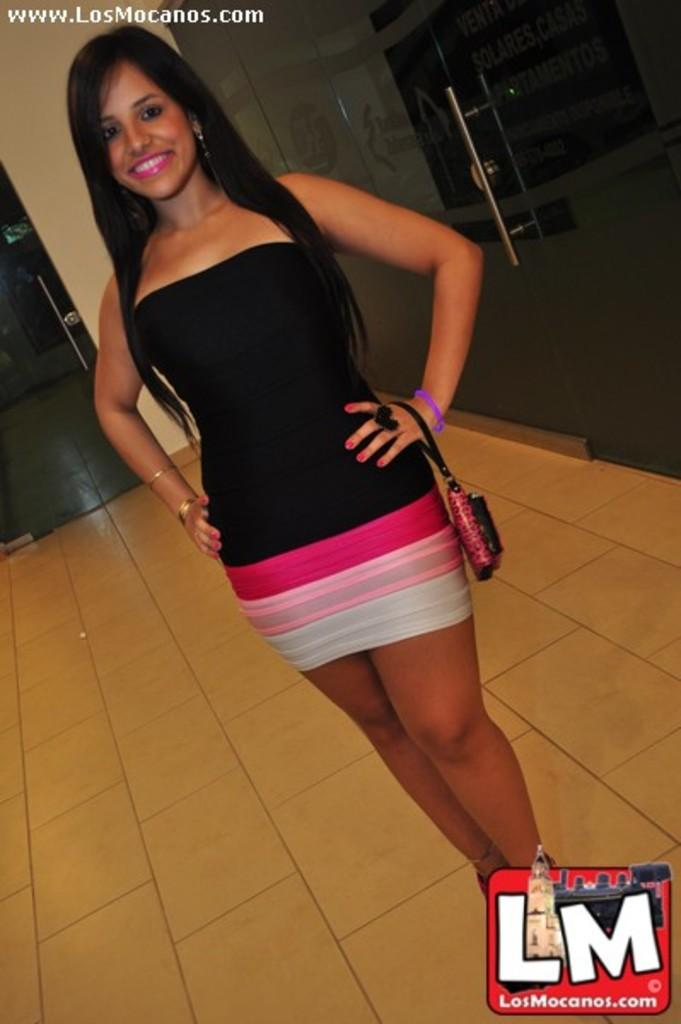Who is the main subject in the image? There is a lady in the image. What is the lady holding in the image? The lady is holding a wallet. What is the lady's posture in the image? The lady is standing in the image. What can be seen in the background of the image? There are doors in the background of the image. Are there any watermarks in the image? Yes, there is a watermark in the top left corner of the image and a watermark in the bottom right corner of the image. How many geese are sitting on the lady's seat in the image? There are no geese present in the image, and the lady is not sitting on a seat. What color is the spot on the lady's shirt in the image? There is no mention of a spot on the lady's shirt in the provided facts. 